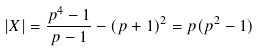<formula> <loc_0><loc_0><loc_500><loc_500>| X | = \frac { p ^ { 4 } - 1 } { p - 1 } - ( p + 1 ) ^ { 2 } = p ( p ^ { 2 } - 1 )</formula> 